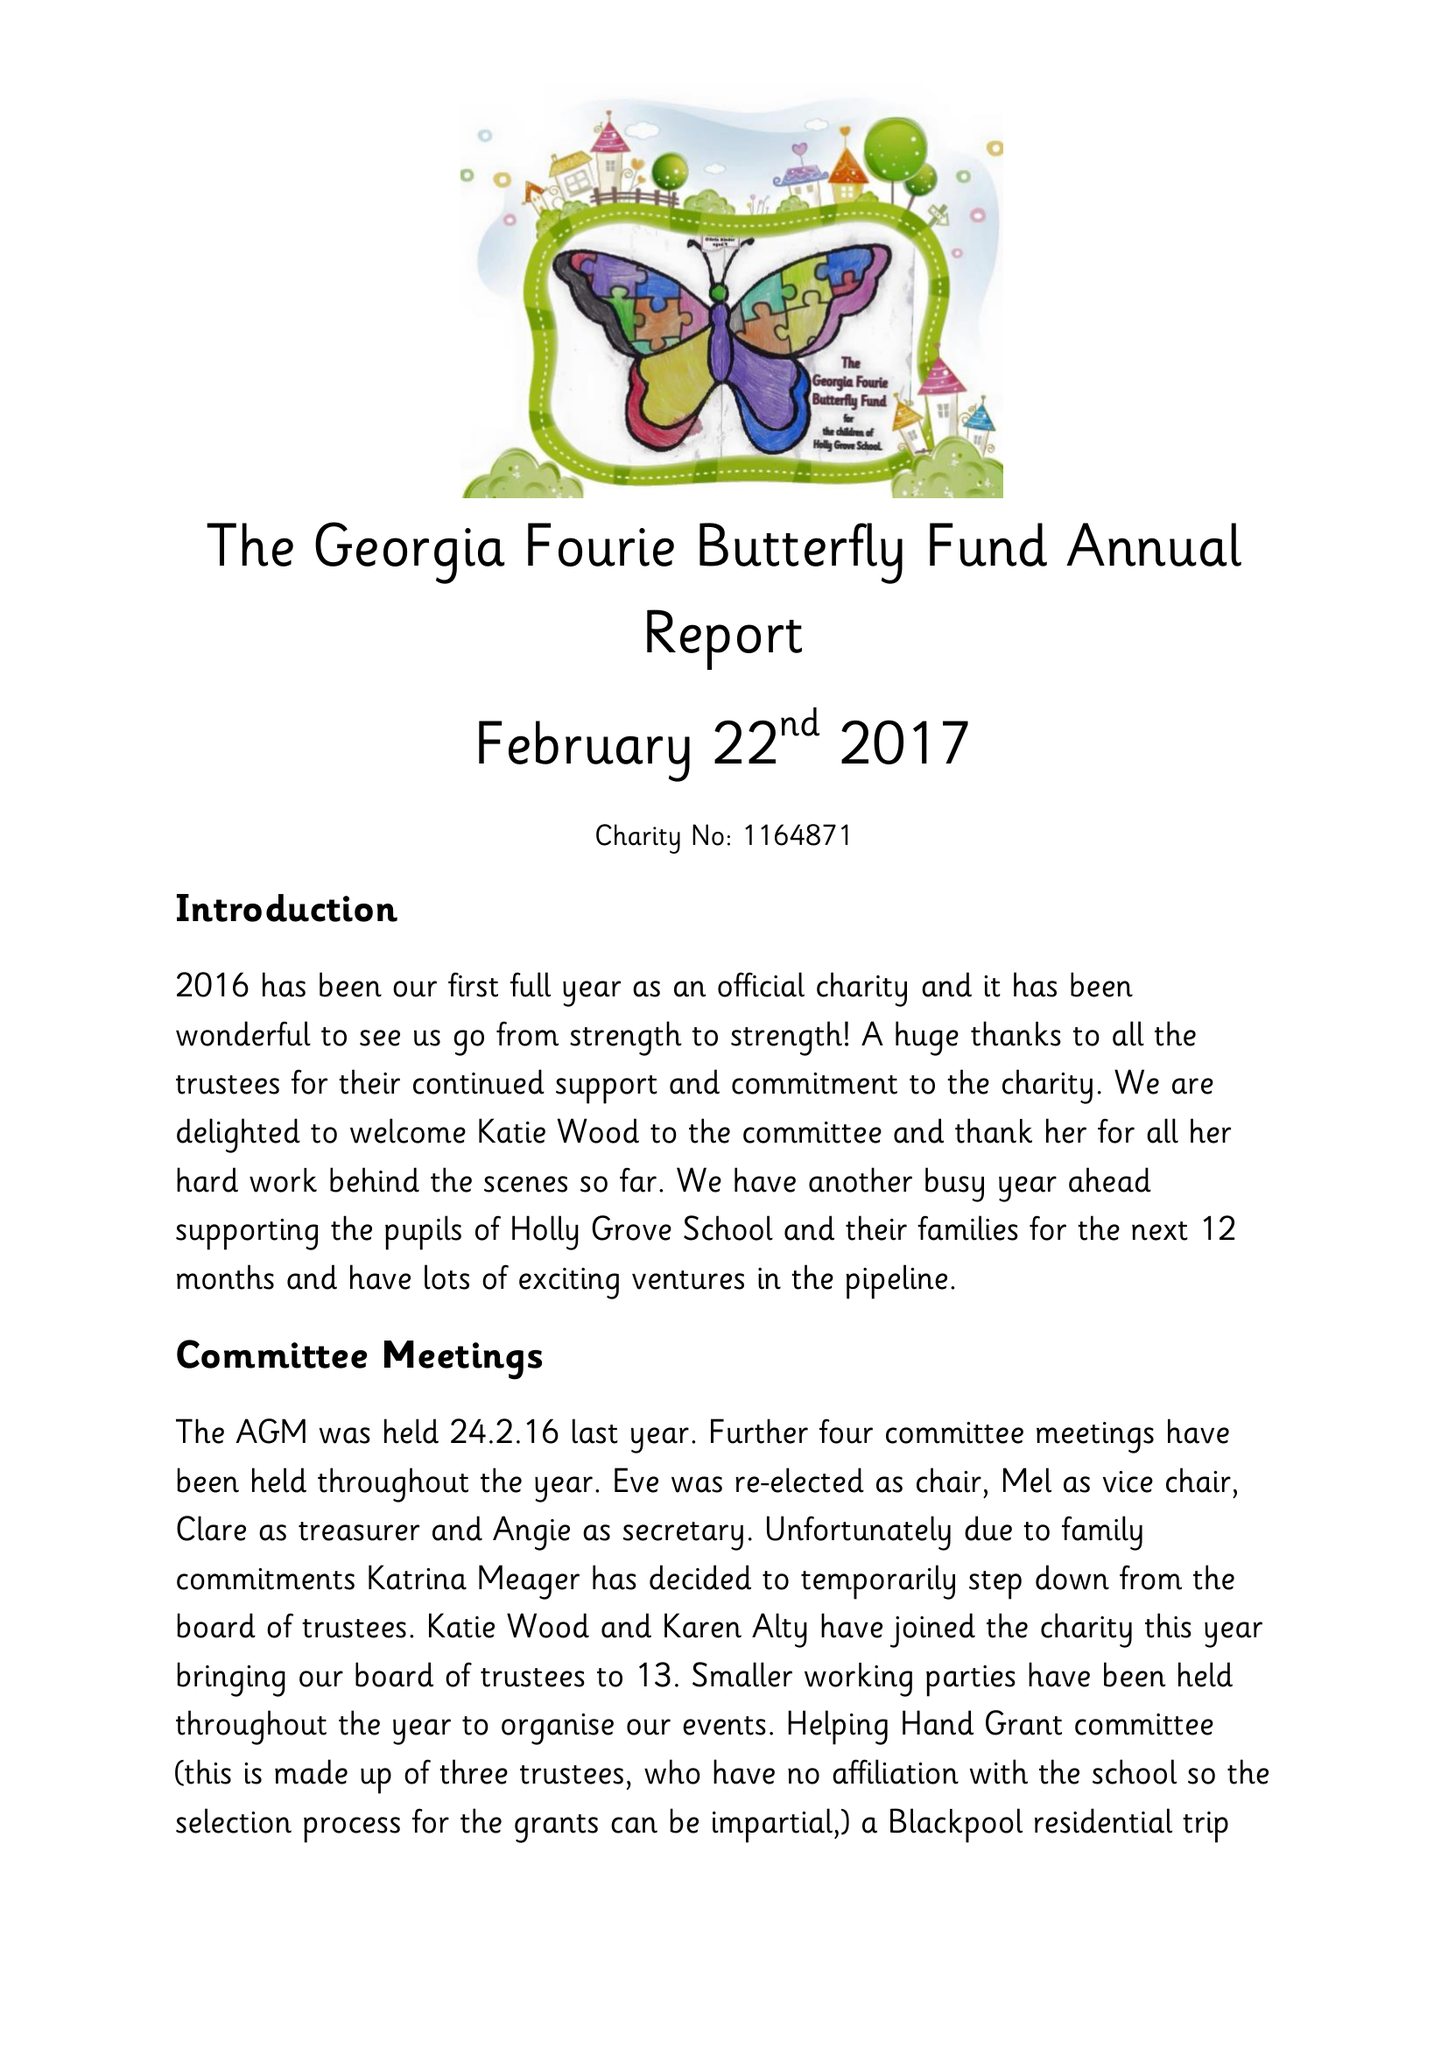What is the value for the charity_name?
Answer the question using a single word or phrase. The Georgia Fourie Butterfly Fund 